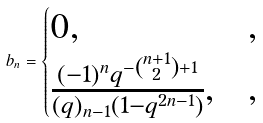Convert formula to latex. <formula><loc_0><loc_0><loc_500><loc_500>b _ { n } = \begin{cases} 0 , & , \\ \frac { ( - 1 ) ^ { n } q ^ { - \binom { n + 1 } { 2 } + 1 } } { ( q ) _ { n - 1 } ( 1 - q ^ { 2 n - 1 } ) } , & , \end{cases}</formula> 